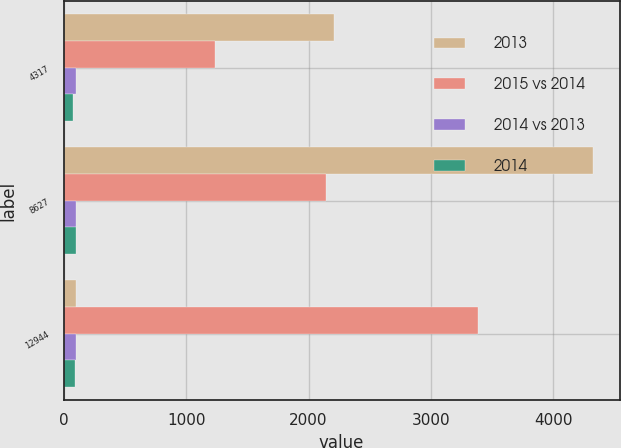Convert chart to OTSL. <chart><loc_0><loc_0><loc_500><loc_500><stacked_bar_chart><ecel><fcel>4317<fcel>8627<fcel>12944<nl><fcel>2013<fcel>2204<fcel>4325<fcel>102<nl><fcel>2015 vs 2014<fcel>1238<fcel>2146<fcel>3384<nl><fcel>2014 vs 2013<fcel>96<fcel>99<fcel>98<nl><fcel>2014<fcel>78<fcel>102<fcel>93<nl></chart> 